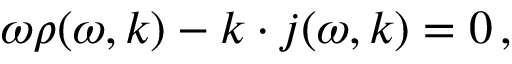Convert formula to latex. <formula><loc_0><loc_0><loc_500><loc_500>\omega \rho ( \omega , k ) - k \cdot j ( \omega , k ) = 0 \, ,</formula> 